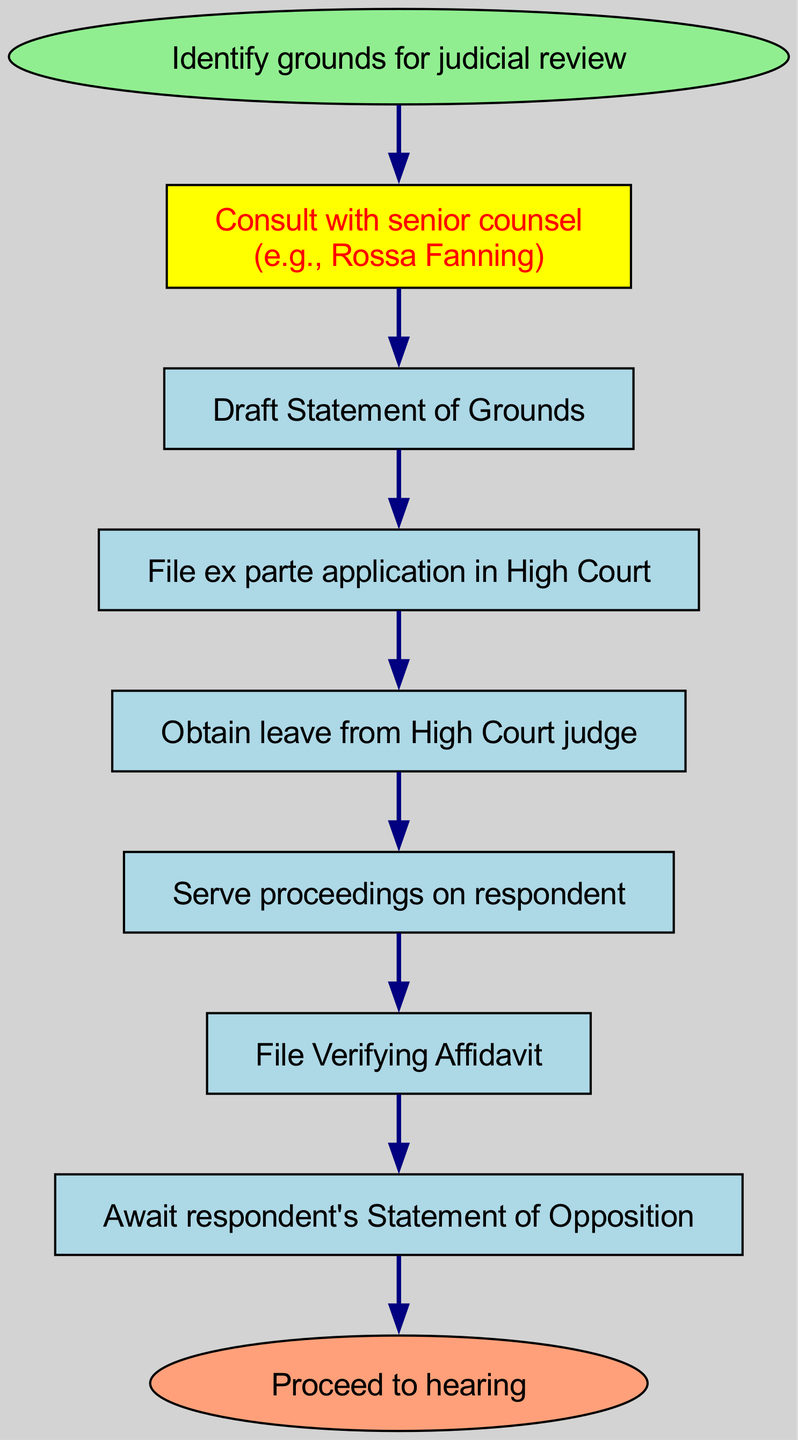What is the first step in the procedure? The first step in the procedure is to identify the grounds for judicial review, as indicated by the initial node labeled "Identify grounds for judicial review."
Answer: Identify grounds for judicial review How many steps are involved in the process? The diagram includes eight steps: starting from "Identify grounds for judicial review" and going through to "Proceed to hearing," which is the final step.
Answer: Eight steps What is the last step before proceeding to the hearing? The last step before proceeding to the hearing is "Await respondent's Statement of Opposition," which is the second to last node in the flow chart.
Answer: Await respondent's Statement of Opposition Which step involves consulting with Rossa Fanning? The step that involves consulting with Rossa Fanning is "Consult with senior counsel (e.g., Rossa Fanning)," which is the second step in the diagram.
Answer: Consult with senior counsel (e.g., Rossa Fanning) How many edges connect to the "File ex parte application in High Court" step? The node "File ex parte application in High Court" has one edge leading into it from "Draft Statement of Grounds" and one edge leading out to "Obtain leave from High Court judge," making a total of two edges connected to this step.
Answer: Two edges What color represents the starting point in the diagram? The starting point, represented by the node "Identify grounds for judicial review," is colored light green according to the diagram's attributes for the start node.
Answer: Light green What action follows after obtaining leave from the High Court judge? Following the action of obtaining leave from the High Court judge, the next action is to "Serve proceedings on respondent," as indicated in the flow's progression.
Answer: Serve proceedings on respondent Which step is associated with filing a Verifying Affidavit? The step associated with filing a Verifying Affidavit is specifically labeled "File Verifying Affidavit," which is the sixth step in the flow chart sequence.
Answer: File Verifying Affidavit What color is used to highlight the consultation with senior counsel? The consultation with senior counsel (e.g., Rossa Fanning) is highlighted in yellow, as specified for that particular step within the diagram.
Answer: Yellow 